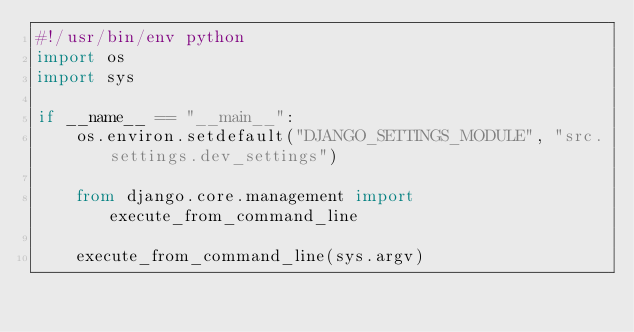Convert code to text. <code><loc_0><loc_0><loc_500><loc_500><_Python_>#!/usr/bin/env python
import os
import sys

if __name__ == "__main__":
    os.environ.setdefault("DJANGO_SETTINGS_MODULE", "src.settings.dev_settings")

    from django.core.management import execute_from_command_line

    execute_from_command_line(sys.argv)
</code> 